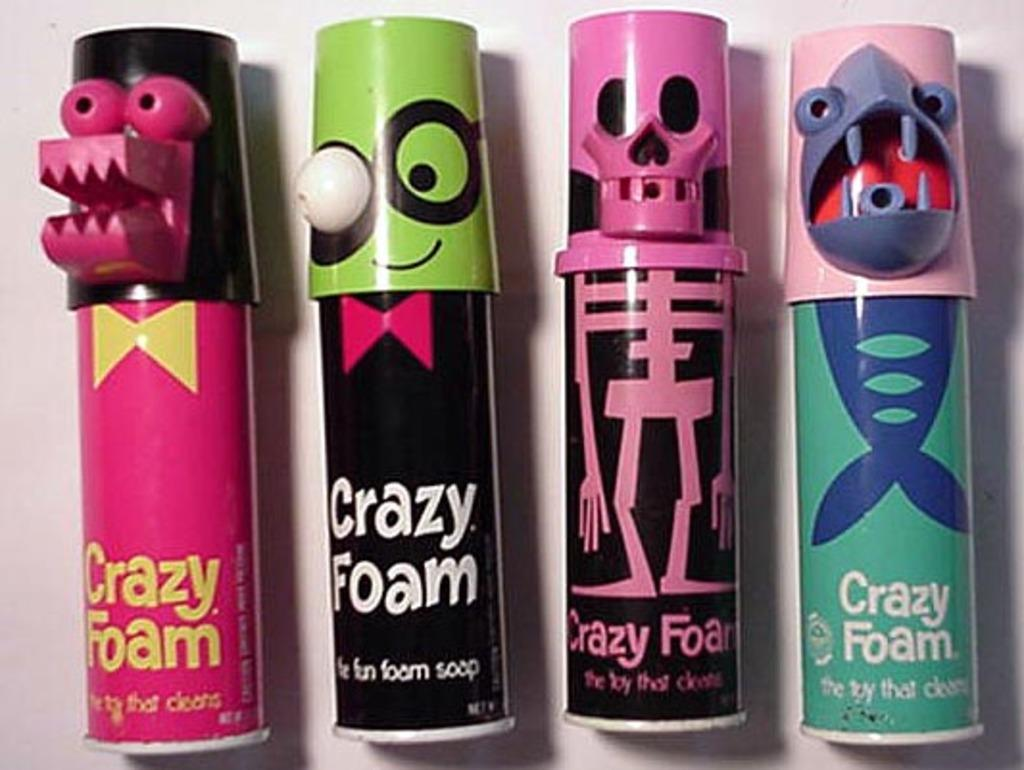What type of product is shown in the image? There are foam sprays in the image. Can you describe the design on the foam spraysprays? The foam sprays have cartoon kids on them. How many eggs does the mind-reading machine in the image require to function? There is no mention of eggs or a mind-reading machine in the image; it only features foam sprays with cartoon kids on them. 